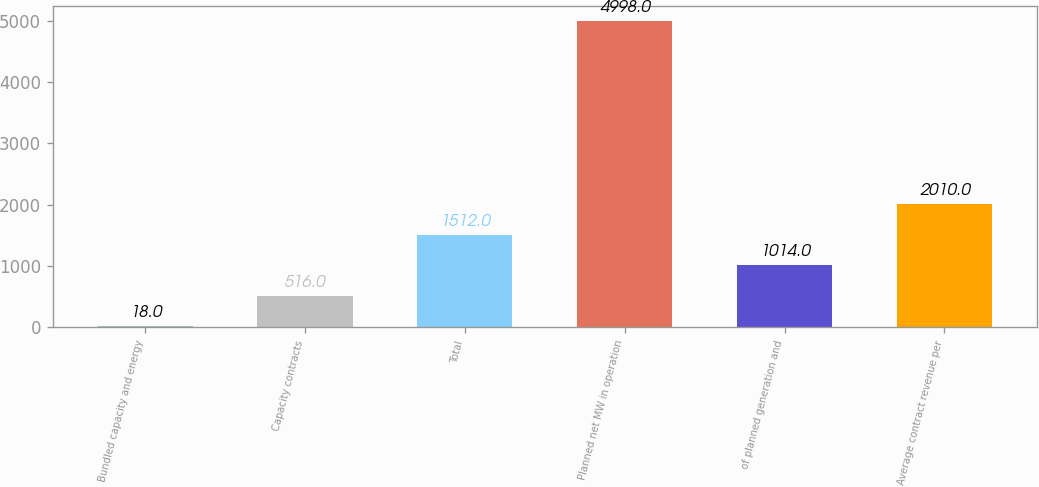<chart> <loc_0><loc_0><loc_500><loc_500><bar_chart><fcel>Bundled capacity and energy<fcel>Capacity contracts<fcel>Total<fcel>Planned net MW in operation<fcel>of planned generation and<fcel>Average contract revenue per<nl><fcel>18<fcel>516<fcel>1512<fcel>4998<fcel>1014<fcel>2010<nl></chart> 